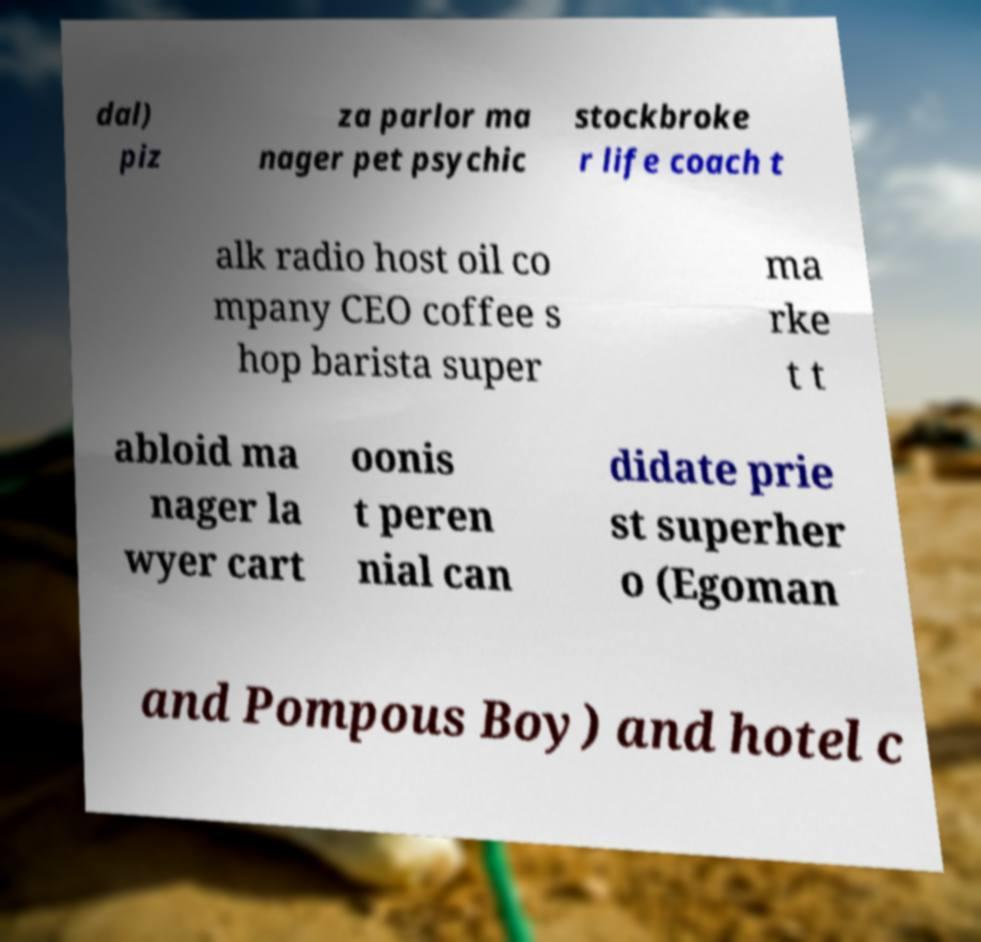I need the written content from this picture converted into text. Can you do that? dal) piz za parlor ma nager pet psychic stockbroke r life coach t alk radio host oil co mpany CEO coffee s hop barista super ma rke t t abloid ma nager la wyer cart oonis t peren nial can didate prie st superher o (Egoman and Pompous Boy) and hotel c 